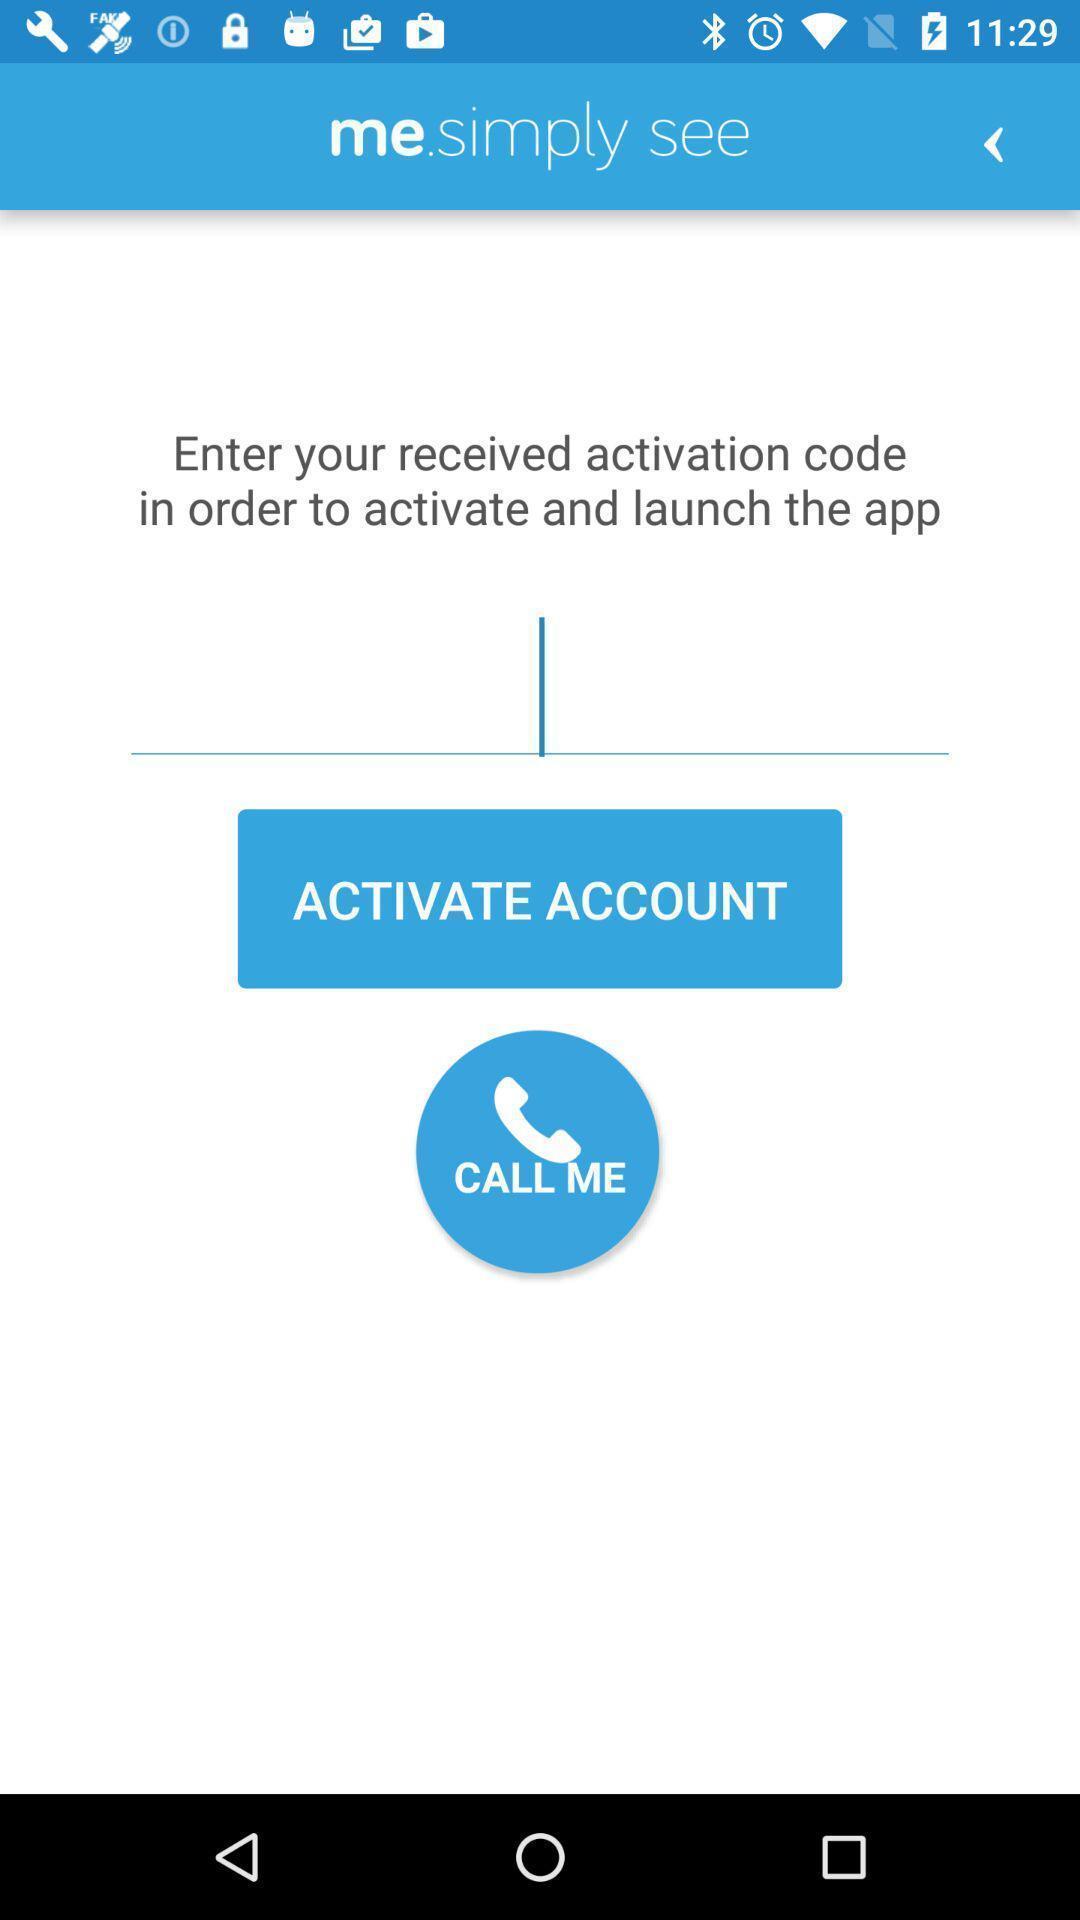Please provide a description for this image. Start page of caller identifier app. 